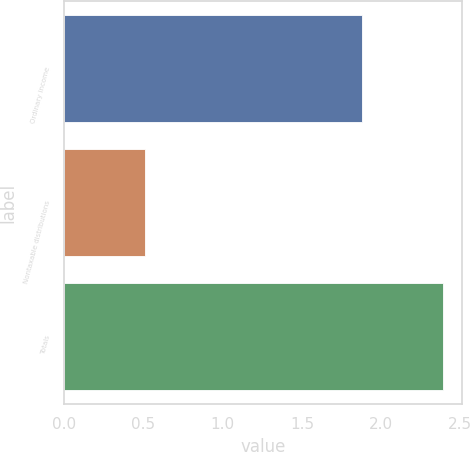Convert chart. <chart><loc_0><loc_0><loc_500><loc_500><bar_chart><fcel>Ordinary income<fcel>Nontaxable distributions<fcel>Totals<nl><fcel>1.88<fcel>0.51<fcel>2.39<nl></chart> 